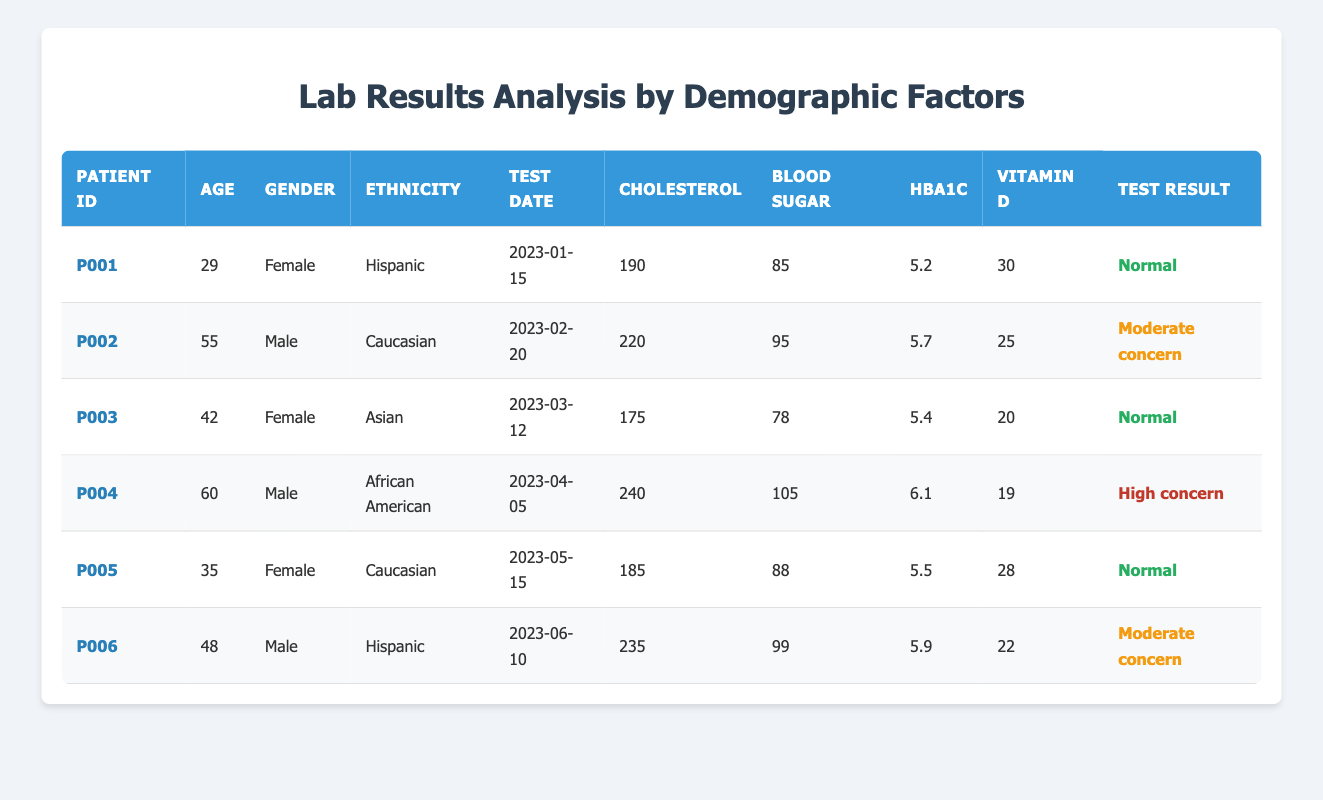What is the cholesterol level of patient P002? The cholesterol level for patient P002 is listed in the table. The corresponding row shows "cholesterolLevel": 220, so this is the value I need.
Answer: 220 How many patients in the table have a test result categorized as "High concern"? In the table, I can see each patient's test result. The only patient marked with "High concern" is patient P004, therefore there is only one patient.
Answer: 1 What is the average blood sugar level among all patients? I need to sum the blood sugar levels for all patients: (85 + 95 + 78 + 105 + 88 + 99) = 550. Since there are 6 patients, I divide 550 by 6 to get the average: 550 / 6 = 91.67.
Answer: 91.67 Is there any female patient with a cholesterol level above 200? I look at the cholesterol levels of the female patients from the table; they are P001, P003, and P005 with levels 190, 175, and 185 respectively. None of them have levels above 200. Thus, the answer is no.
Answer: No What is the vitamin D level of the oldest patient in the table? The oldest patient is patient P004, aged 60, and the vitamin D level is specified in the same row as their other details. Therefore, I can look it up and find "vitaminDLevel": 19.
Answer: 19 How many patients are of Hispanic ethnicity and what are their test results? I find the patients with Hispanic ethnicity in the table, which are P001 and P006. Their test results are "Normal" and "Moderate concern" respectively. Therefore, two patients fit this category.
Answer: 2, "Normal" and "Moderate concern" Among males, who has the highest hemoglobin A1c level, and what is it? I assess the hemoglobin A1c levels of the male patients: P002 has 5.7, P004 has 6.1, and P006 has 5.9. The highest level is from patient P004.
Answer: P004, 6.1 What percentage of patients have a normal test result? There are 6 patients in total, and I see that 3 of them have a "Normal" test result. To find the percentage, I divide 3 by 6 and multiply by 100: (3 / 6) * 100 = 50%.
Answer: 50% Is patient P005 older than patient P003? I compare their ages directly from the table. Patient P005 is 35, and patient P003 is 42. Since 35 is less than 42, the answer is no.
Answer: No 